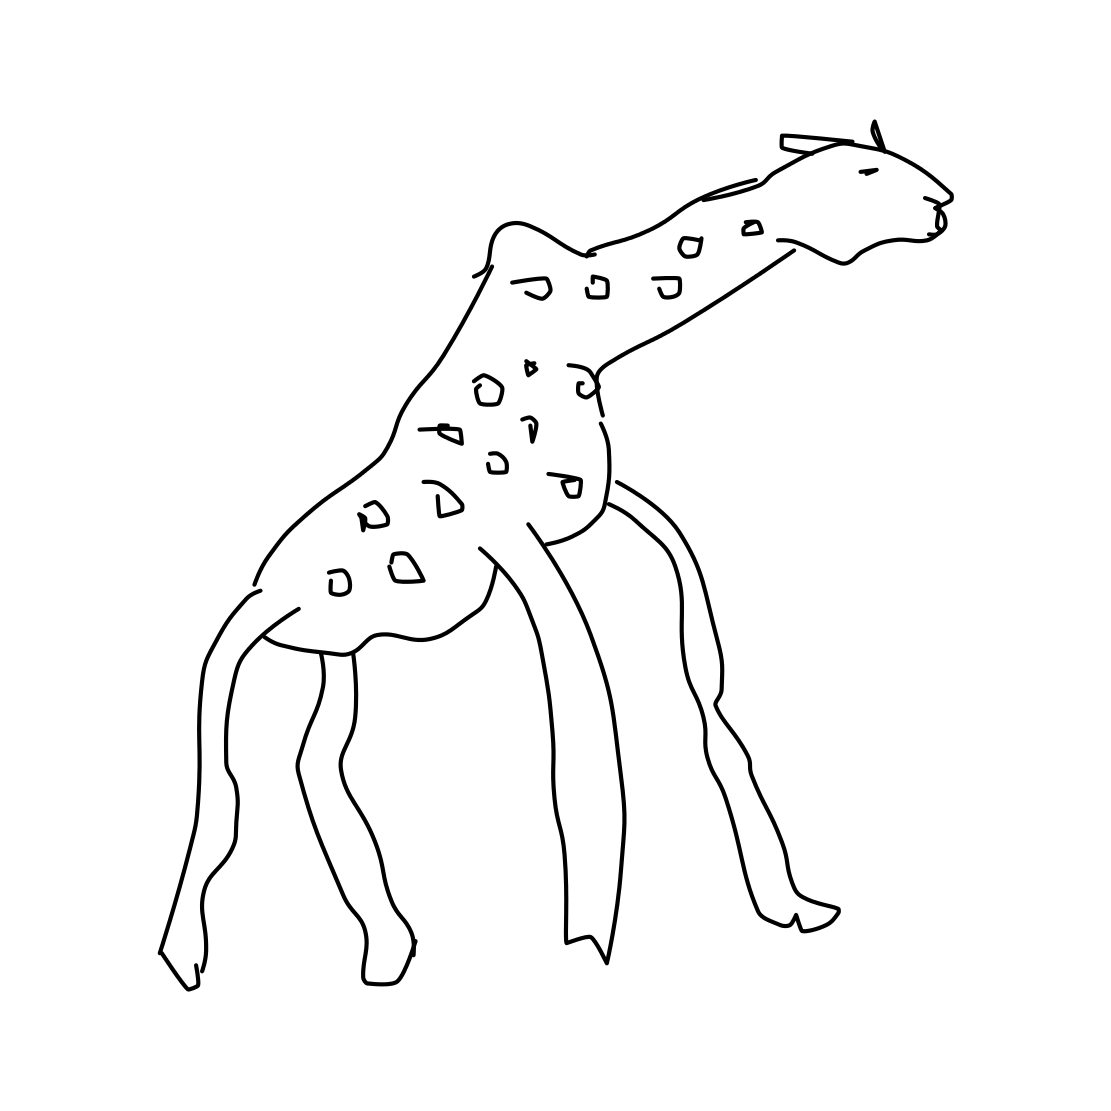What characteristics can you tell me about the giraffe? The giraffe in the image is depicted with its iconic long neck and legs, as well as the characteristic spots on its body. However, as it's a line drawing, it lacks detail and color that would be present in a more realistic portrayal. 